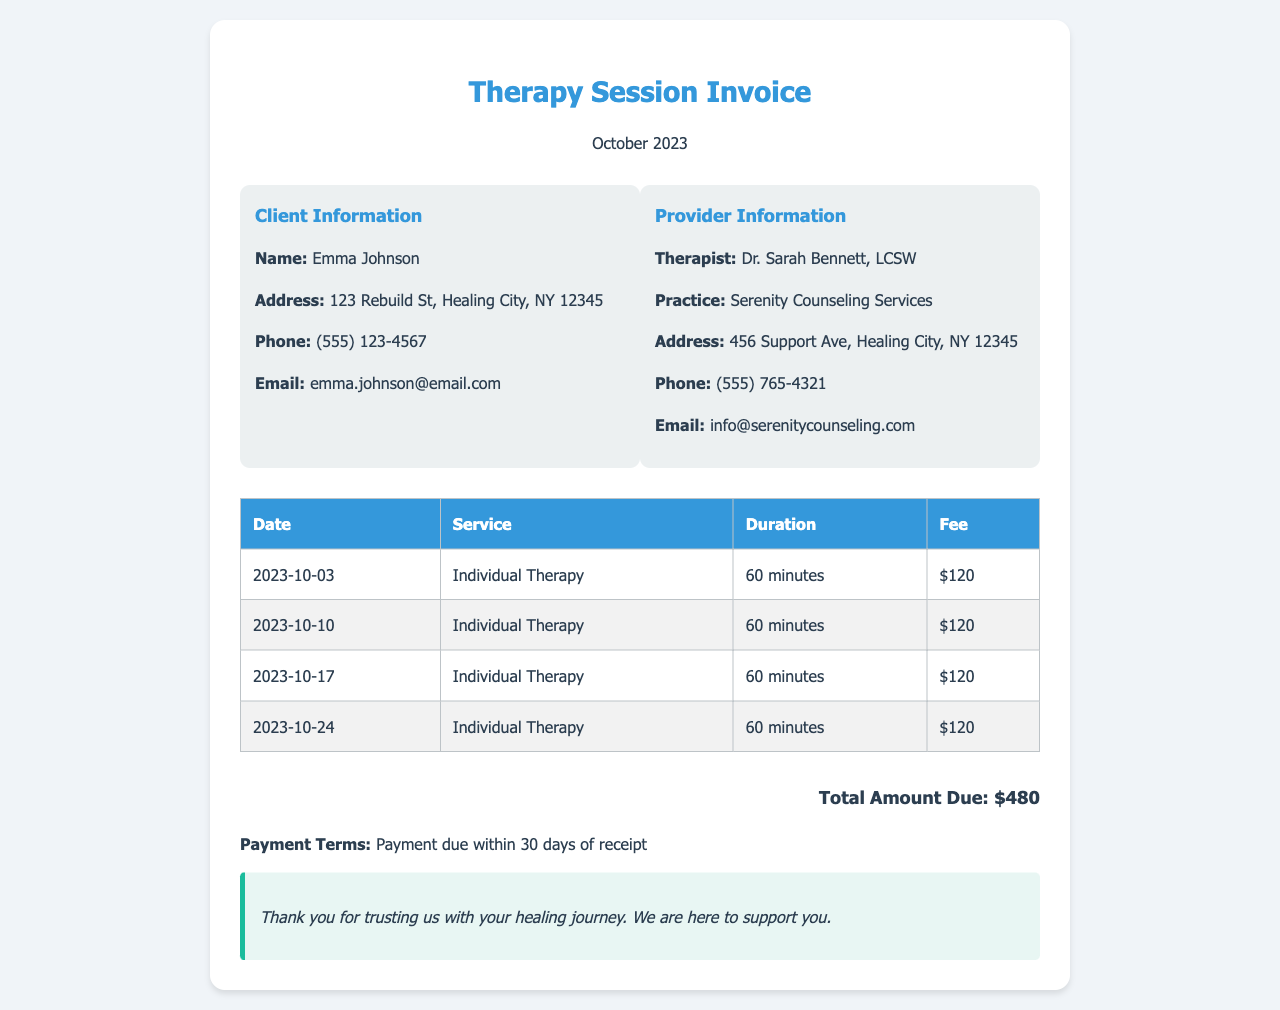what is the client's name? The document lists the client's name in the client information section.
Answer: Emma Johnson what is the therapist's name? The therapist's name is specified in the provider information section.
Answer: Dr. Sarah Bennett, LCSW how many therapy sessions occurred in October 2023? The number of sessions can be counted from the session dates listed in the table.
Answer: 4 what is the duration of each therapy session? The duration for all sessions is consistently mentioned in the table under the Duration column.
Answer: 60 minutes what is the total amount due for therapy sessions? The total amount is calculated and presented at the bottom of the document.
Answer: $480 what is the service provided? The type of service is specified multiple times in the document.
Answer: Individual Therapy when was the first therapy session? The first session date is listed in the table.
Answer: 2023-10-03 what are the payment terms? The payment terms are mentioned in the notes section of the invoice.
Answer: Payment due within 30 days of receipt where is the practice located? The practice address is provided in the provider information section of the document.
Answer: 456 Support Ave, Healing City, NY 12345 